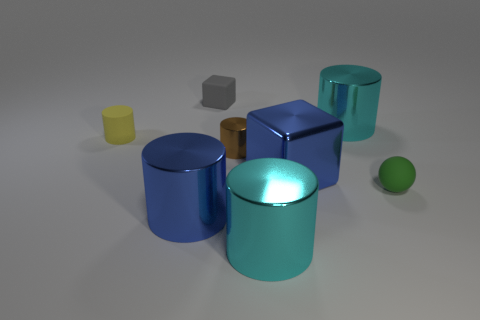Is there a pattern to the arrangement of the objects, and if so, what does it suggest about their relationship? The objects do not exhibit a clear pattern in their arrangement. They are placed at varying distances from each other without a discernible order, suggesting no intentional relationship between the objects beyond their physical proximity. 